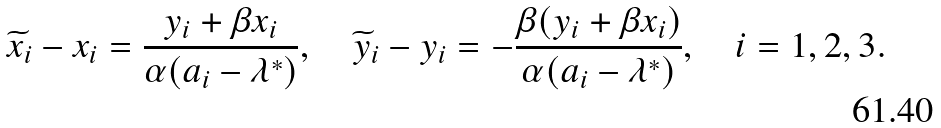<formula> <loc_0><loc_0><loc_500><loc_500>\widetilde { x } _ { i } - x _ { i } = \frac { y _ { i } + \beta x _ { i } } { \alpha ( a _ { i } - \lambda ^ { * } ) } , \quad \widetilde { y } _ { i } - y _ { i } = - \frac { \beta ( y _ { i } + \beta x _ { i } ) } { \alpha ( a _ { i } - \lambda ^ { * } ) } , \quad i = 1 , 2 , 3 .</formula> 